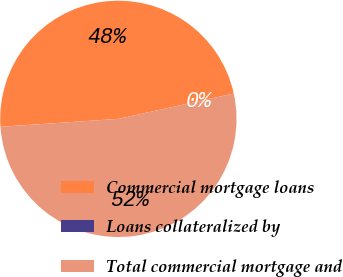Convert chart to OTSL. <chart><loc_0><loc_0><loc_500><loc_500><pie_chart><fcel>Commercial mortgage loans<fcel>Loans collateralized by<fcel>Total commercial mortgage and<nl><fcel>47.62%<fcel>0.01%<fcel>52.38%<nl></chart> 